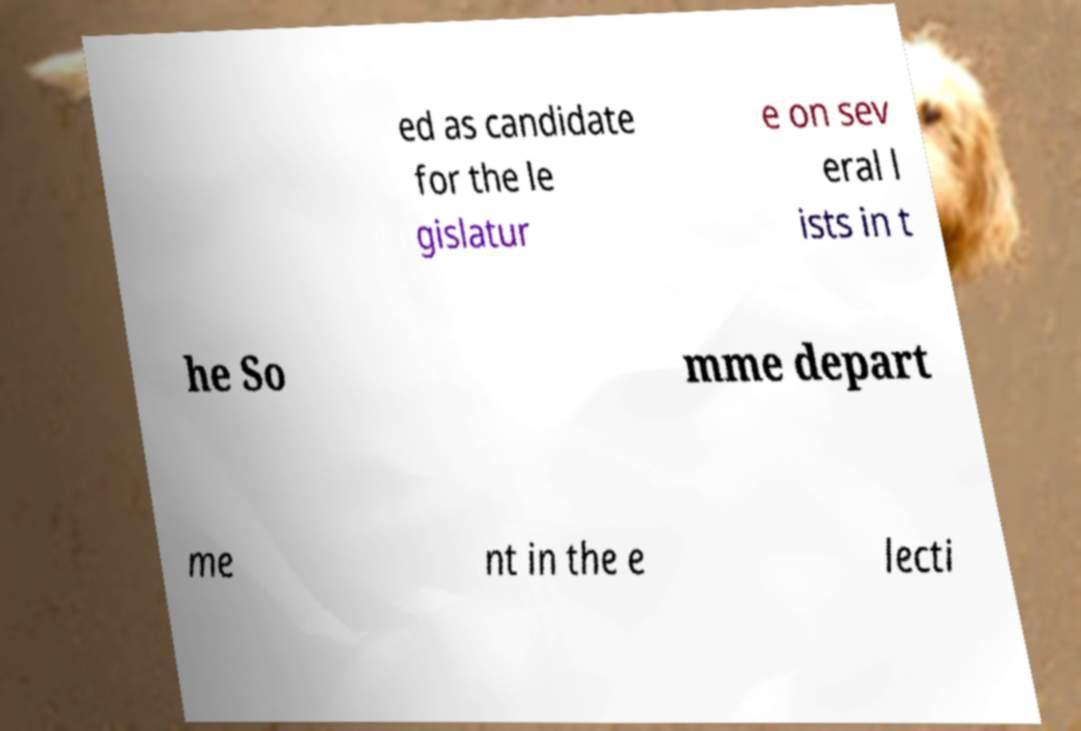Please identify and transcribe the text found in this image. ed as candidate for the le gislatur e on sev eral l ists in t he So mme depart me nt in the e lecti 